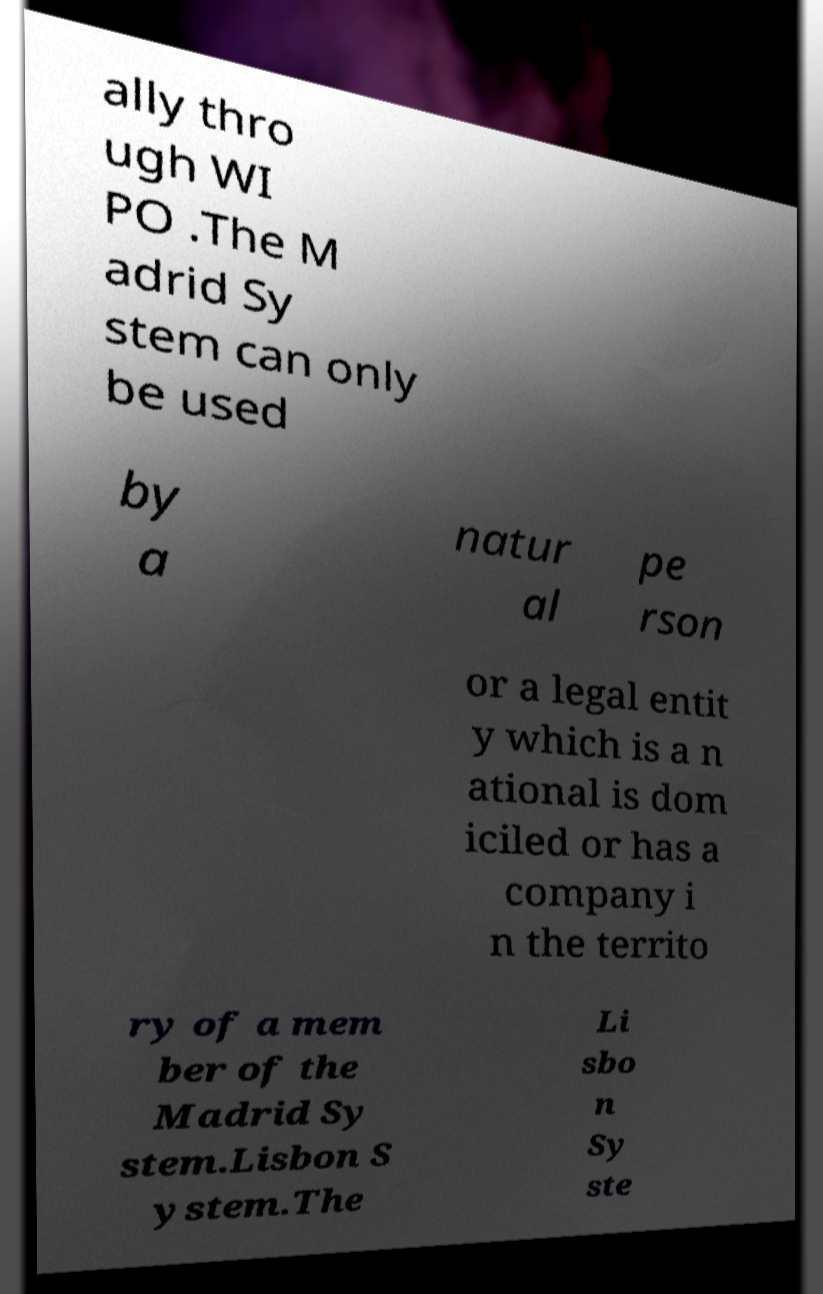What messages or text are displayed in this image? I need them in a readable, typed format. ally thro ugh WI PO .The M adrid Sy stem can only be used by a natur al pe rson or a legal entit y which is a n ational is dom iciled or has a company i n the territo ry of a mem ber of the Madrid Sy stem.Lisbon S ystem.The Li sbo n Sy ste 